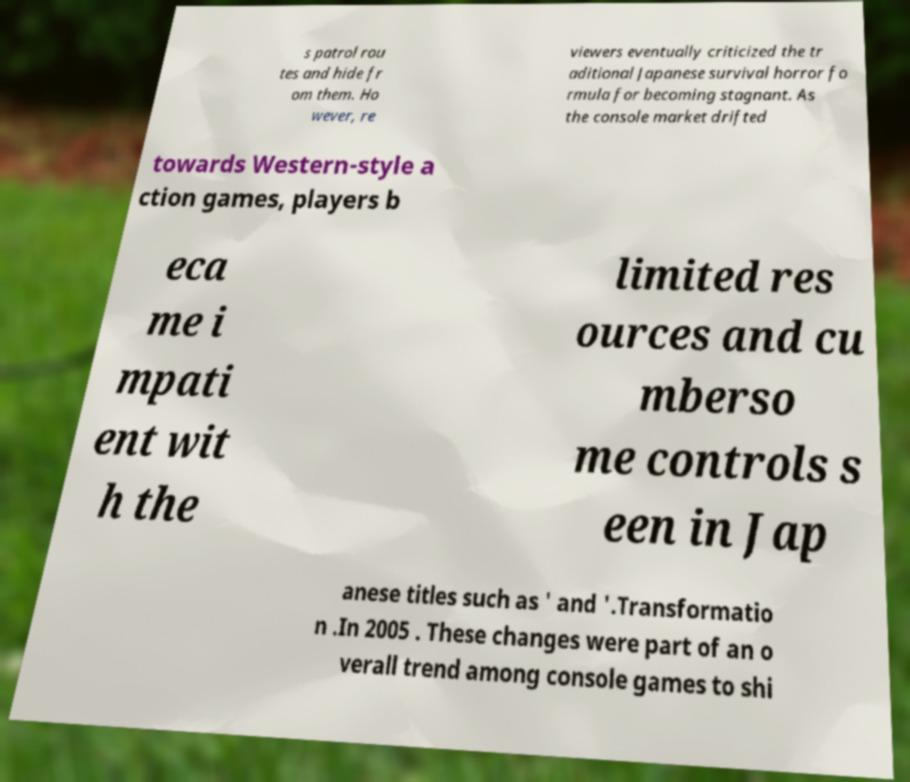Please read and relay the text visible in this image. What does it say? s patrol rou tes and hide fr om them. Ho wever, re viewers eventually criticized the tr aditional Japanese survival horror fo rmula for becoming stagnant. As the console market drifted towards Western-style a ction games, players b eca me i mpati ent wit h the limited res ources and cu mberso me controls s een in Jap anese titles such as ' and '.Transformatio n .In 2005 . These changes were part of an o verall trend among console games to shi 